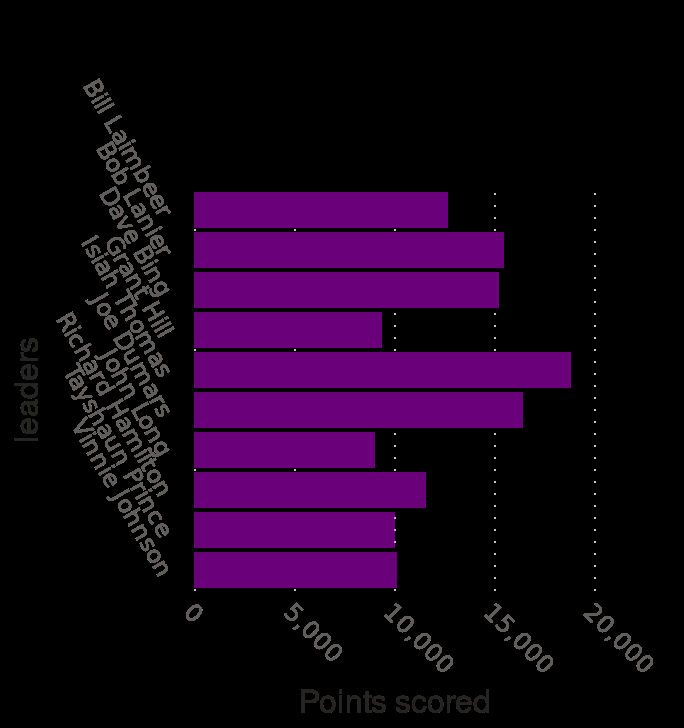<image>
What does the y-axis measure on the bar graph?  The y-axis measures leaders as a categorical scale. How many leaders are listed in the bar chart? The number of leaders listed in the bar chart is not mentioned in the description. 